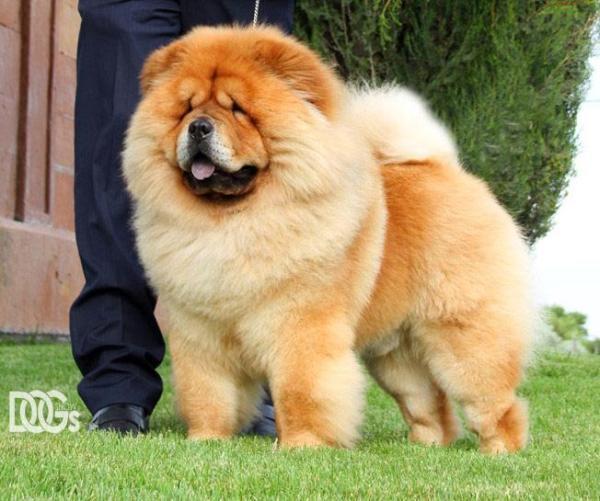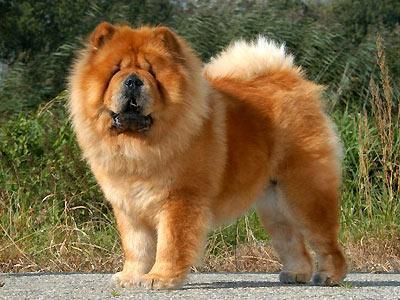The first image is the image on the left, the second image is the image on the right. Examine the images to the left and right. Is the description "There are only two brown dogs in the pair of images." accurate? Answer yes or no. Yes. The first image is the image on the left, the second image is the image on the right. Considering the images on both sides, is "The right image contains exactly one chow whose body is facing towards the left and their face is looking at the camera." valid? Answer yes or no. Yes. 